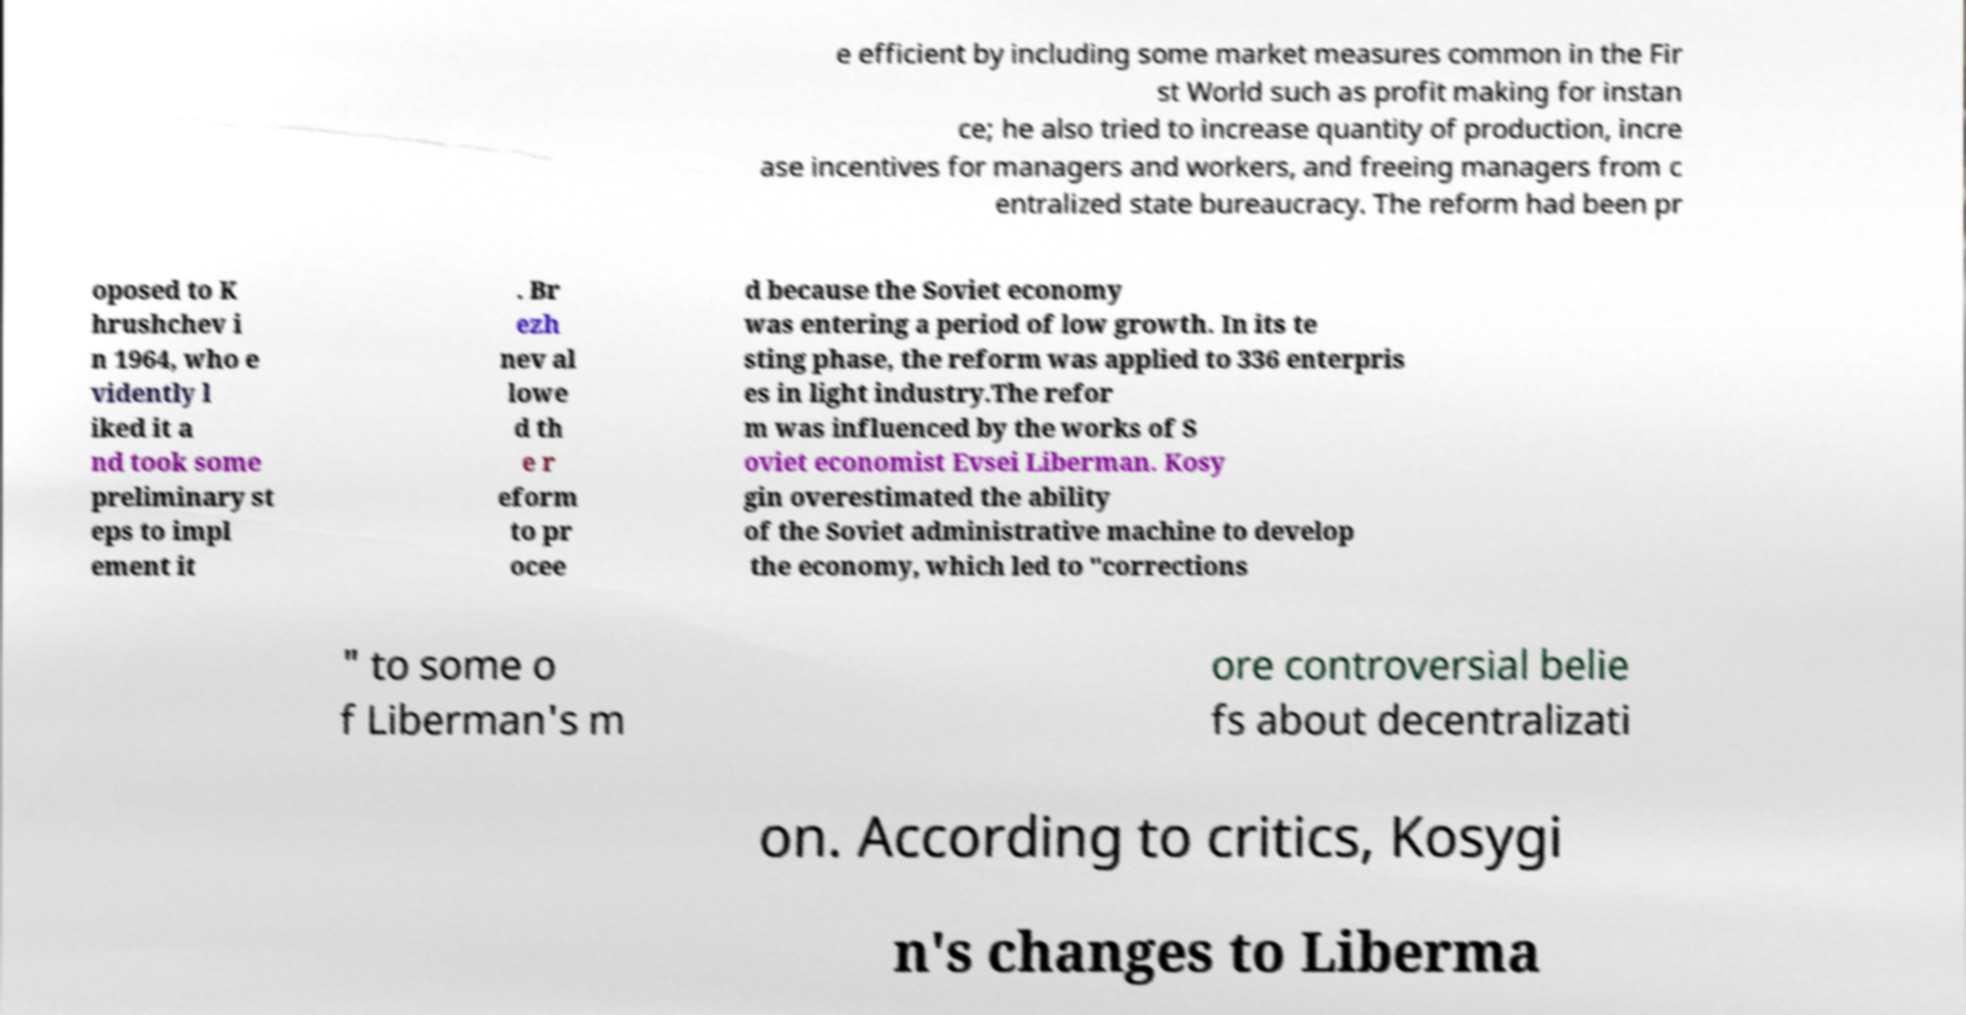For documentation purposes, I need the text within this image transcribed. Could you provide that? e efficient by including some market measures common in the Fir st World such as profit making for instan ce; he also tried to increase quantity of production, incre ase incentives for managers and workers, and freeing managers from c entralized state bureaucracy. The reform had been pr oposed to K hrushchev i n 1964, who e vidently l iked it a nd took some preliminary st eps to impl ement it . Br ezh nev al lowe d th e r eform to pr ocee d because the Soviet economy was entering a period of low growth. In its te sting phase, the reform was applied to 336 enterpris es in light industry.The refor m was influenced by the works of S oviet economist Evsei Liberman. Kosy gin overestimated the ability of the Soviet administrative machine to develop the economy, which led to "corrections " to some o f Liberman's m ore controversial belie fs about decentralizati on. According to critics, Kosygi n's changes to Liberma 